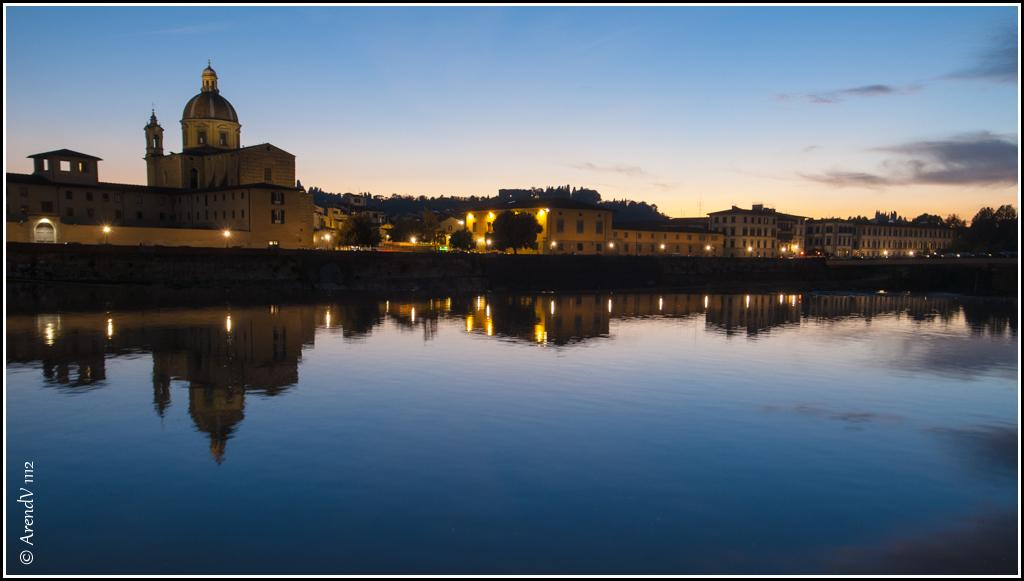What is at the bottom of the image? There is water at the bottom of the image. What can be seen in the background of the image? There are buildings with lights in the background. What is visible at the top of the image? The sky is visible at the top of the image. What type of vegetation is present between the houses in the background? There are trees between the houses in the background. Can you tell me how many fans are visible in the image? There are no fans present in the image. What type of drum can be seen being played in the image? There is no drum present in the image. 